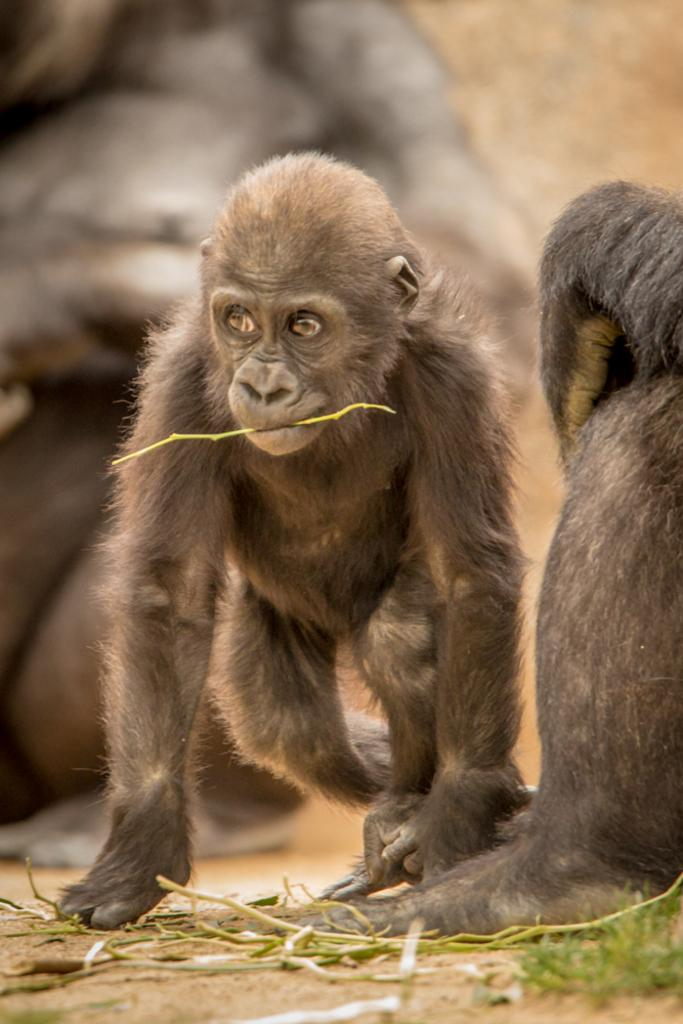What animals are present in the image? There are gorillas in the image. What color are the gorillas? The gorillas are brown in color. What can be seen on the ground in the image? There are plant stems on the ground in the image. How would you describe the background of the image? The background of the image is blurred. What type of soup is being served at the gorilla's birthday party in the image? There is no soup or birthday party present in the image; it features gorillas and plant stems on the ground. How does the comb help the gorillas in the image? There is no comb present in the image, and therefore it cannot help the gorillas. 